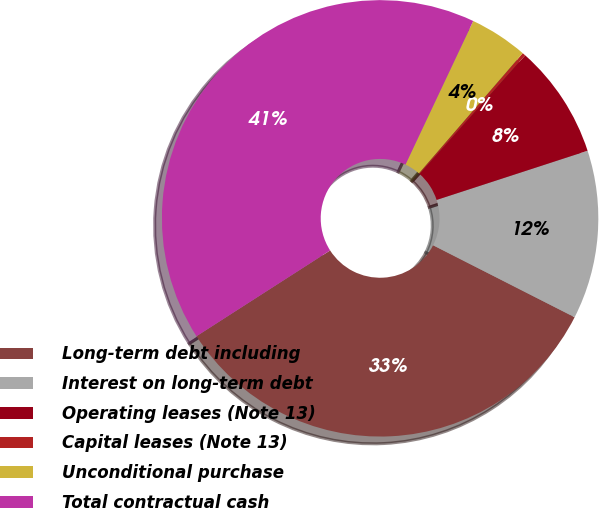<chart> <loc_0><loc_0><loc_500><loc_500><pie_chart><fcel>Long-term debt including<fcel>Interest on long-term debt<fcel>Operating leases (Note 13)<fcel>Capital leases (Note 13)<fcel>Unconditional purchase<fcel>Total contractual cash<nl><fcel>33.43%<fcel>12.5%<fcel>8.41%<fcel>0.24%<fcel>4.32%<fcel>41.1%<nl></chart> 